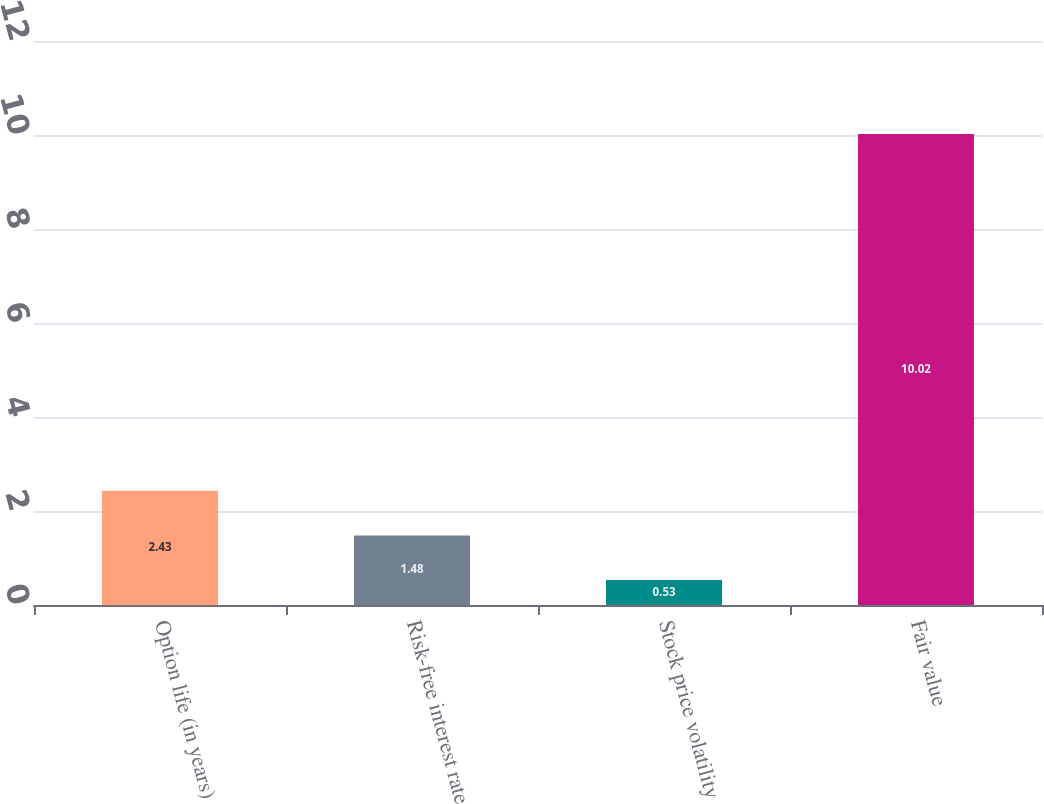Convert chart. <chart><loc_0><loc_0><loc_500><loc_500><bar_chart><fcel>Option life (in years)<fcel>Risk-free interest rate<fcel>Stock price volatility<fcel>Fair value<nl><fcel>2.43<fcel>1.48<fcel>0.53<fcel>10.02<nl></chart> 